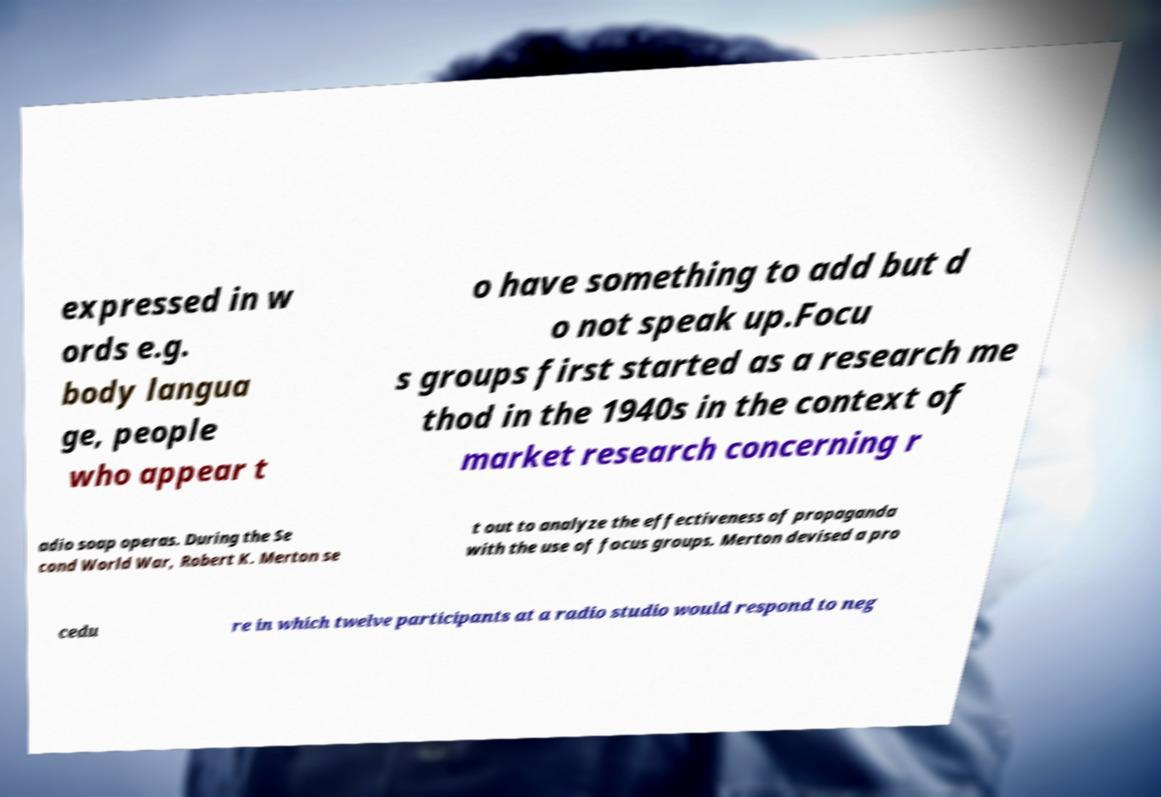There's text embedded in this image that I need extracted. Can you transcribe it verbatim? expressed in w ords e.g. body langua ge, people who appear t o have something to add but d o not speak up.Focu s groups first started as a research me thod in the 1940s in the context of market research concerning r adio soap operas. During the Se cond World War, Robert K. Merton se t out to analyze the effectiveness of propaganda with the use of focus groups. Merton devised a pro cedu re in which twelve participants at a radio studio would respond to neg 